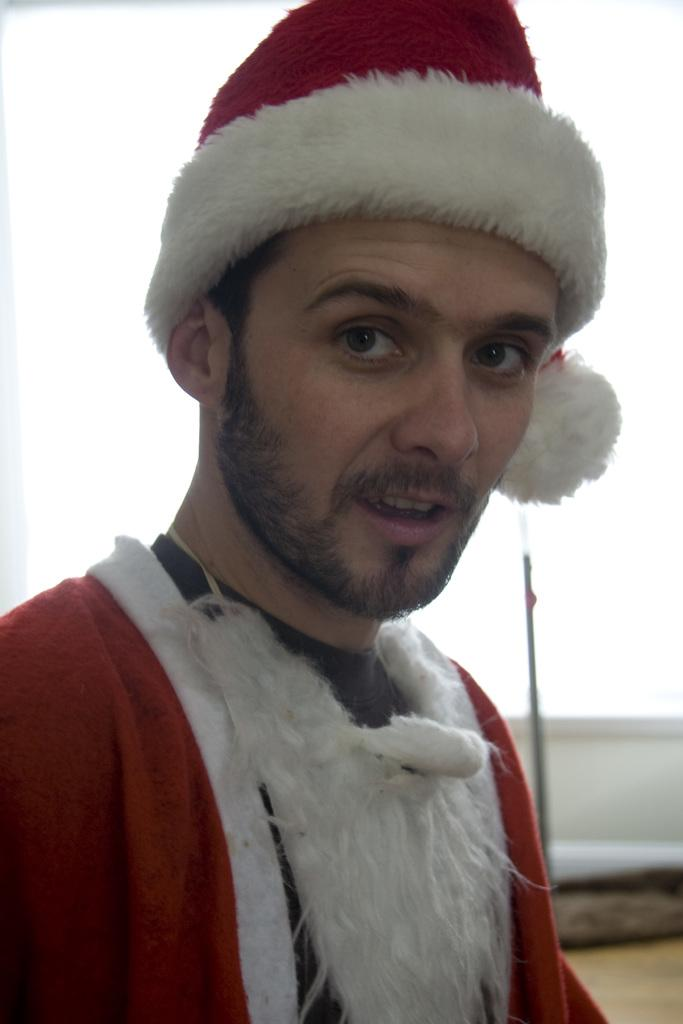Who is the main subject in the image? There is a man in the middle of the picture. What is the man wearing in the image? The man is wearing a red and white color dress and a cap on his head. Can you describe the background of the image? The background of the image is blurred. What type of cow can be seen grazing in the background of the image? There is no cow present in the image; the background is blurred. What kind of loaf is the man holding in the image? The man is not holding any loaf in the image; he is wearing a red and white color dress and a cap on his head. 